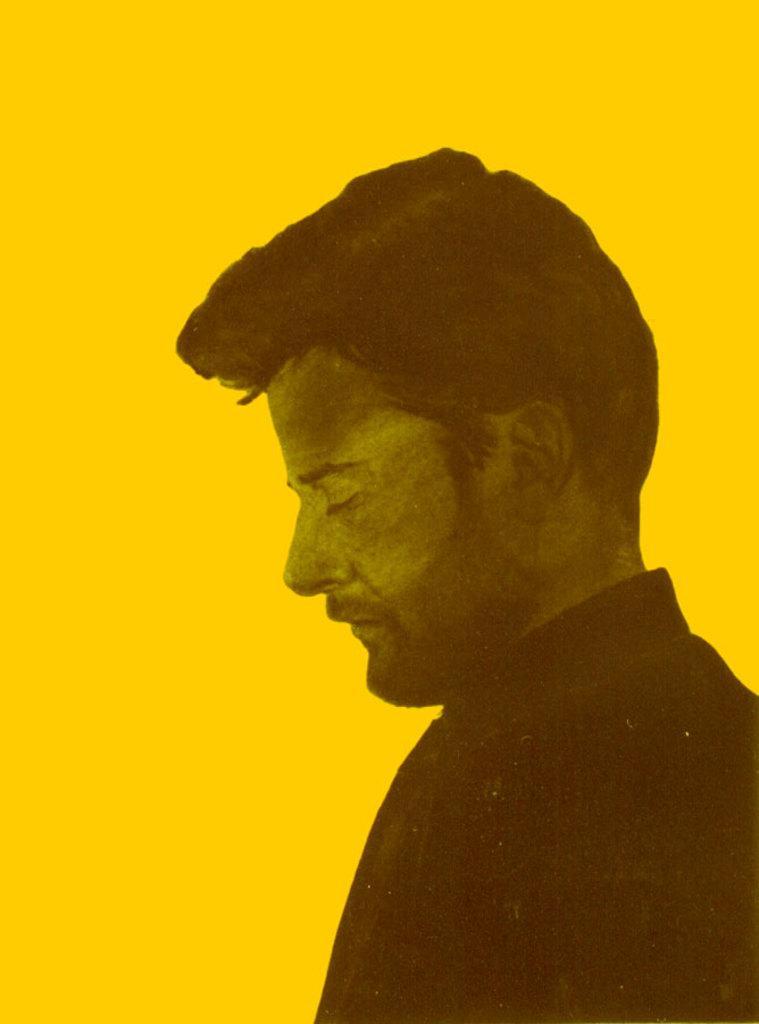Could you give a brief overview of what you see in this image? It is an edited image, there is a picture of a man and behind the man there is a yellow background. 